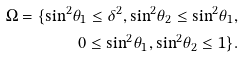<formula> <loc_0><loc_0><loc_500><loc_500>{ \Omega } = \{ { { \sin } ^ { 2 } } { \theta _ { 1 } } \leq { \delta ^ { 2 } } , { { \sin } ^ { 2 } } { \theta _ { 2 } } \leq { { \sin } ^ { 2 } } { \theta _ { 1 } } , \\ 0 \leq { { \sin } ^ { 2 } } { \theta _ { 1 } } , { { \sin } ^ { 2 } } { \theta _ { 2 } } \leq 1 \} .</formula> 